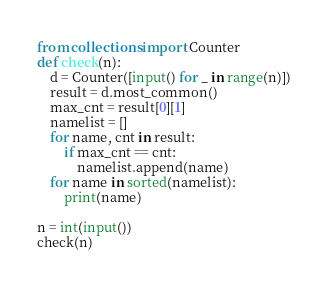Convert code to text. <code><loc_0><loc_0><loc_500><loc_500><_Python_>from collections import Counter
def check(n):
    d = Counter([input() for _ in range(n)])
    result = d.most_common()
    max_cnt = result[0][1]
    namelist = []
    for name, cnt in result:
        if max_cnt == cnt:
            namelist.append(name)
    for name in sorted(namelist):
        print(name)
    
n = int(input())
check(n)</code> 